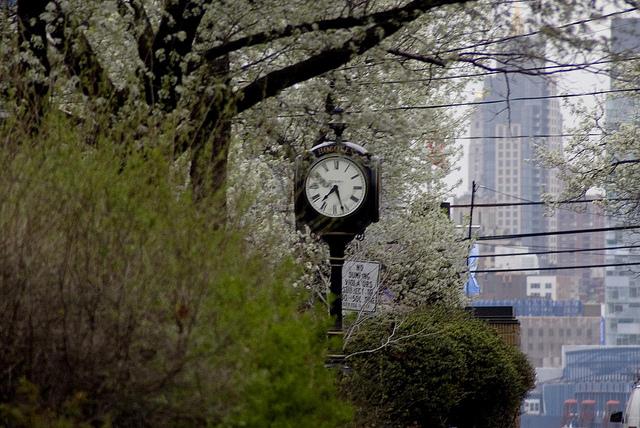How many trees appear in this photo?
Short answer required. 3. What building is the clock on?
Write a very short answer. No building. Does this clock face have the correct time?
Quick response, please. Yes. Does the clock have numbers on it?
Keep it brief. No. Is this a colorful city?
Quick response, please. Yes. What time is it?
Quick response, please. 7:25. What time does the clock read?
Give a very brief answer. 7:26. How long must you wait for a bus if you arrive at 6AM?
Write a very short answer. 2 hours. What time does the clock show?
Short answer required. 7:27. What time is it on the clock?
Give a very brief answer. 7:27. What time does the clock have?
Be succinct. 7:27. 